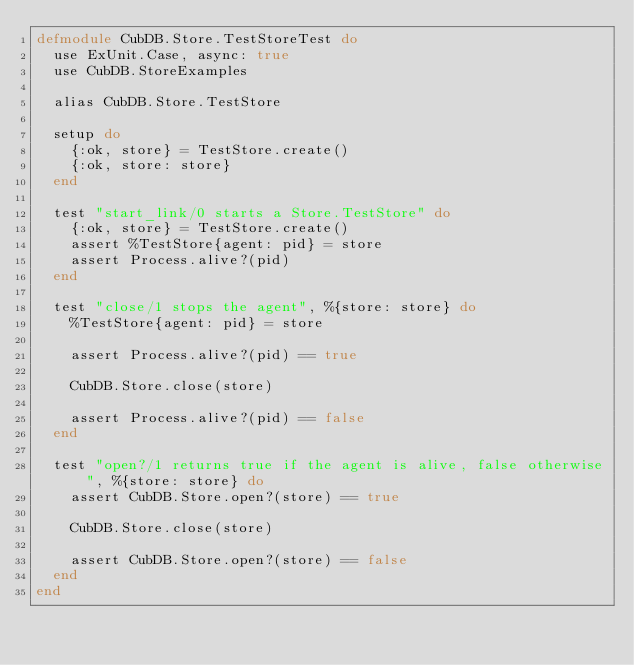Convert code to text. <code><loc_0><loc_0><loc_500><loc_500><_Elixir_>defmodule CubDB.Store.TestStoreTest do
  use ExUnit.Case, async: true
  use CubDB.StoreExamples

  alias CubDB.Store.TestStore

  setup do
    {:ok, store} = TestStore.create()
    {:ok, store: store}
  end

  test "start_link/0 starts a Store.TestStore" do
    {:ok, store} = TestStore.create()
    assert %TestStore{agent: pid} = store
    assert Process.alive?(pid)
  end

  test "close/1 stops the agent", %{store: store} do
    %TestStore{agent: pid} = store

    assert Process.alive?(pid) == true

    CubDB.Store.close(store)

    assert Process.alive?(pid) == false
  end

  test "open?/1 returns true if the agent is alive, false otherwise", %{store: store} do
    assert CubDB.Store.open?(store) == true

    CubDB.Store.close(store)

    assert CubDB.Store.open?(store) == false
  end
end
</code> 